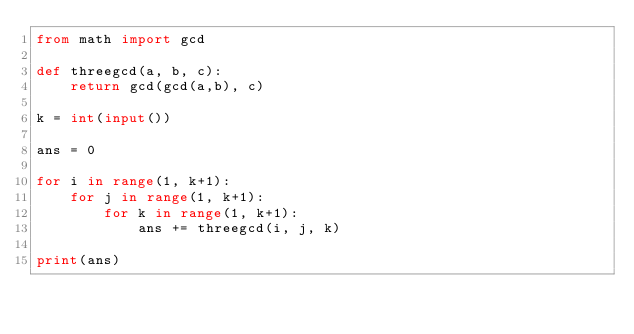Convert code to text. <code><loc_0><loc_0><loc_500><loc_500><_Python_>from math import gcd

def threegcd(a, b, c):
    return gcd(gcd(a,b), c)

k = int(input())

ans = 0

for i in range(1, k+1):
    for j in range(1, k+1):
        for k in range(1, k+1):
            ans += threegcd(i, j, k)

print(ans)</code> 